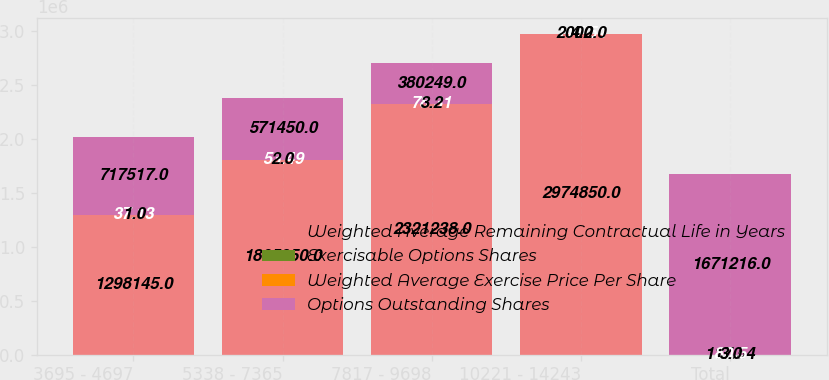Convert chart. <chart><loc_0><loc_0><loc_500><loc_500><stacked_bar_chart><ecel><fcel>3695 - 4697<fcel>5338 - 7365<fcel>7817 - 9698<fcel>10221 - 14243<fcel>Total<nl><fcel>Weighted Average Remaining Contractual Life in Years<fcel>1.29814e+06<fcel>1.80595e+06<fcel>2.32124e+06<fcel>2.97485e+06<fcel>117.54<nl><fcel>Exercisable Options Shares<fcel>37.13<fcel>53.49<fcel>78.31<fcel>117.54<fcel>80.5<nl><fcel>Weighted Average Exercise Price Per Share<fcel>1<fcel>2<fcel>3.2<fcel>4.2<fcel>3<nl><fcel>Options Outstanding Shares<fcel>717517<fcel>571450<fcel>380249<fcel>2000<fcel>1.67122e+06<nl></chart> 